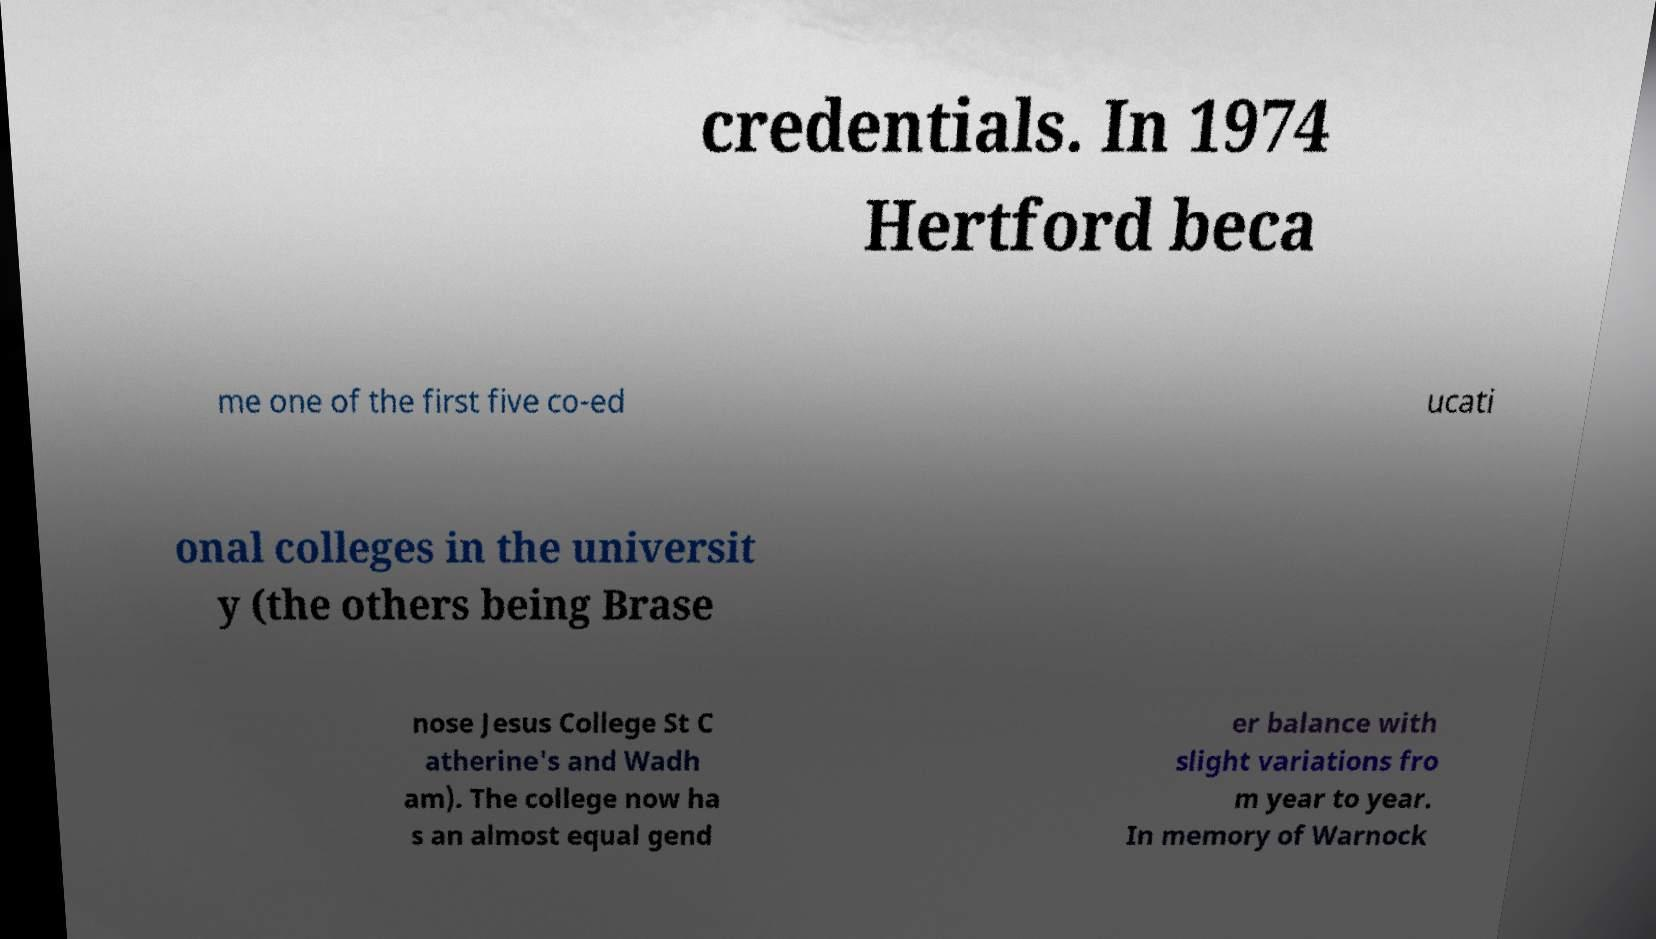There's text embedded in this image that I need extracted. Can you transcribe it verbatim? credentials. In 1974 Hertford beca me one of the first five co-ed ucati onal colleges in the universit y (the others being Brase nose Jesus College St C atherine's and Wadh am). The college now ha s an almost equal gend er balance with slight variations fro m year to year. In memory of Warnock 